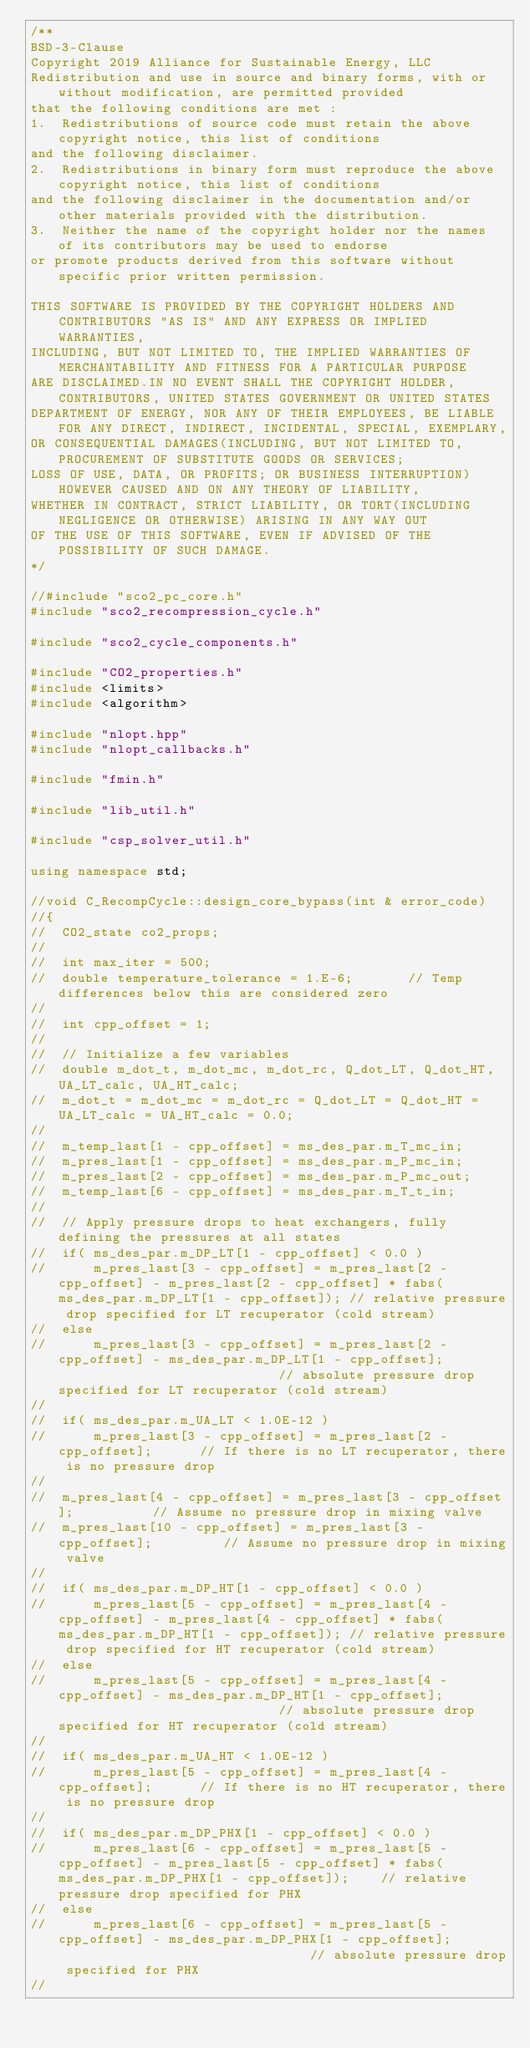Convert code to text. <code><loc_0><loc_0><loc_500><loc_500><_C++_>/**
BSD-3-Clause
Copyright 2019 Alliance for Sustainable Energy, LLC
Redistribution and use in source and binary forms, with or without modification, are permitted provided 
that the following conditions are met :
1.	Redistributions of source code must retain the above copyright notice, this list of conditions 
and the following disclaimer.
2.	Redistributions in binary form must reproduce the above copyright notice, this list of conditions 
and the following disclaimer in the documentation and/or other materials provided with the distribution.
3.	Neither the name of the copyright holder nor the names of its contributors may be used to endorse 
or promote products derived from this software without specific prior written permission.

THIS SOFTWARE IS PROVIDED BY THE COPYRIGHT HOLDERS AND CONTRIBUTORS "AS IS" AND ANY EXPRESS OR IMPLIED WARRANTIES, 
INCLUDING, BUT NOT LIMITED TO, THE IMPLIED WARRANTIES OF MERCHANTABILITY AND FITNESS FOR A PARTICULAR PURPOSE 
ARE DISCLAIMED.IN NO EVENT SHALL THE COPYRIGHT HOLDER, CONTRIBUTORS, UNITED STATES GOVERNMENT OR UNITED STATES 
DEPARTMENT OF ENERGY, NOR ANY OF THEIR EMPLOYEES, BE LIABLE FOR ANY DIRECT, INDIRECT, INCIDENTAL, SPECIAL, EXEMPLARY, 
OR CONSEQUENTIAL DAMAGES(INCLUDING, BUT NOT LIMITED TO, PROCUREMENT OF SUBSTITUTE GOODS OR SERVICES; 
LOSS OF USE, DATA, OR PROFITS; OR BUSINESS INTERRUPTION) HOWEVER CAUSED AND ON ANY THEORY OF LIABILITY, 
WHETHER IN CONTRACT, STRICT LIABILITY, OR TORT(INCLUDING NEGLIGENCE OR OTHERWISE) ARISING IN ANY WAY OUT 
OF THE USE OF THIS SOFTWARE, EVEN IF ADVISED OF THE POSSIBILITY OF SUCH DAMAGE.
*/

//#include "sco2_pc_core.h"
#include "sco2_recompression_cycle.h"

#include "sco2_cycle_components.h"

#include "CO2_properties.h"
#include <limits>
#include <algorithm>

#include "nlopt.hpp"
#include "nlopt_callbacks.h"

#include "fmin.h"

#include "lib_util.h"

#include "csp_solver_util.h"

using namespace std;

//void C_RecompCycle::design_core_bypass(int & error_code)
//{
//	CO2_state co2_props;
//
//	int max_iter = 500;
//	double temperature_tolerance = 1.E-6;		// Temp differences below this are considered zero
//
//	int cpp_offset = 1;
//
//	// Initialize a few variables
//	double m_dot_t, m_dot_mc, m_dot_rc, Q_dot_LT, Q_dot_HT, UA_LT_calc, UA_HT_calc;
//	m_dot_t = m_dot_mc = m_dot_rc = Q_dot_LT = Q_dot_HT = UA_LT_calc = UA_HT_calc = 0.0;
//
//	m_temp_last[1 - cpp_offset] = ms_des_par.m_T_mc_in;
//	m_pres_last[1 - cpp_offset] = ms_des_par.m_P_mc_in;
//	m_pres_last[2 - cpp_offset] = ms_des_par.m_P_mc_out;
//	m_temp_last[6 - cpp_offset] = ms_des_par.m_T_t_in;
//
//	// Apply pressure drops to heat exchangers, fully defining the pressures at all states
//	if( ms_des_par.m_DP_LT[1 - cpp_offset] < 0.0 )
//		m_pres_last[3 - cpp_offset] = m_pres_last[2 - cpp_offset] - m_pres_last[2 - cpp_offset] * fabs(ms_des_par.m_DP_LT[1 - cpp_offset]);	// relative pressure drop specified for LT recuperator (cold stream)
//	else
//		m_pres_last[3 - cpp_offset] = m_pres_last[2 - cpp_offset] - ms_des_par.m_DP_LT[1 - cpp_offset];									// absolute pressure drop specified for LT recuperator (cold stream)
//
//	if( ms_des_par.m_UA_LT < 1.0E-12 )
//		m_pres_last[3 - cpp_offset] = m_pres_last[2 - cpp_offset];		// If there is no LT recuperator, there is no pressure drop
//
//	m_pres_last[4 - cpp_offset] = m_pres_last[3 - cpp_offset];			// Assume no pressure drop in mixing valve
//	m_pres_last[10 - cpp_offset] = m_pres_last[3 - cpp_offset];			// Assume no pressure drop in mixing valve
//
//	if( ms_des_par.m_DP_HT[1 - cpp_offset] < 0.0 )
//		m_pres_last[5 - cpp_offset] = m_pres_last[4 - cpp_offset] - m_pres_last[4 - cpp_offset] * fabs(ms_des_par.m_DP_HT[1 - cpp_offset]);	// relative pressure drop specified for HT recuperator (cold stream)
//	else
//		m_pres_last[5 - cpp_offset] = m_pres_last[4 - cpp_offset] - ms_des_par.m_DP_HT[1 - cpp_offset];									// absolute pressure drop specified for HT recuperator (cold stream)
//
//	if( ms_des_par.m_UA_HT < 1.0E-12 )
//		m_pres_last[5 - cpp_offset] = m_pres_last[4 - cpp_offset];		// If there is no HT recuperator, there is no pressure drop
//
//	if( ms_des_par.m_DP_PHX[1 - cpp_offset] < 0.0 )
//		m_pres_last[6 - cpp_offset] = m_pres_last[5 - cpp_offset] - m_pres_last[5 - cpp_offset] * fabs(ms_des_par.m_DP_PHX[1 - cpp_offset]);	// relative pressure drop specified for PHX
//	else
//		m_pres_last[6 - cpp_offset] = m_pres_last[5 - cpp_offset] - ms_des_par.m_DP_PHX[1 - cpp_offset];									// absolute pressure drop specified for PHX
//</code> 